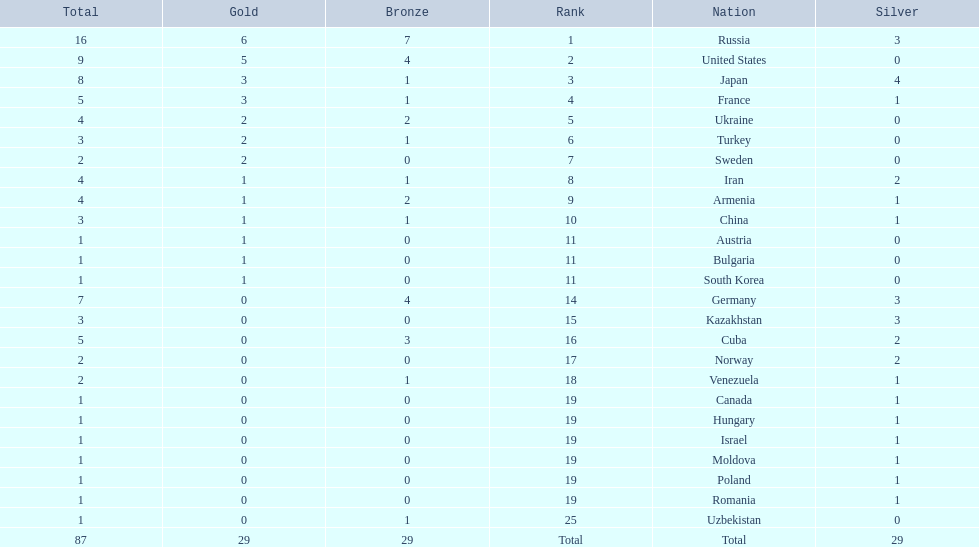Where did iran rank? 8. Where did germany rank? 14. Which of those did make it into the top 10 rank? Germany. 